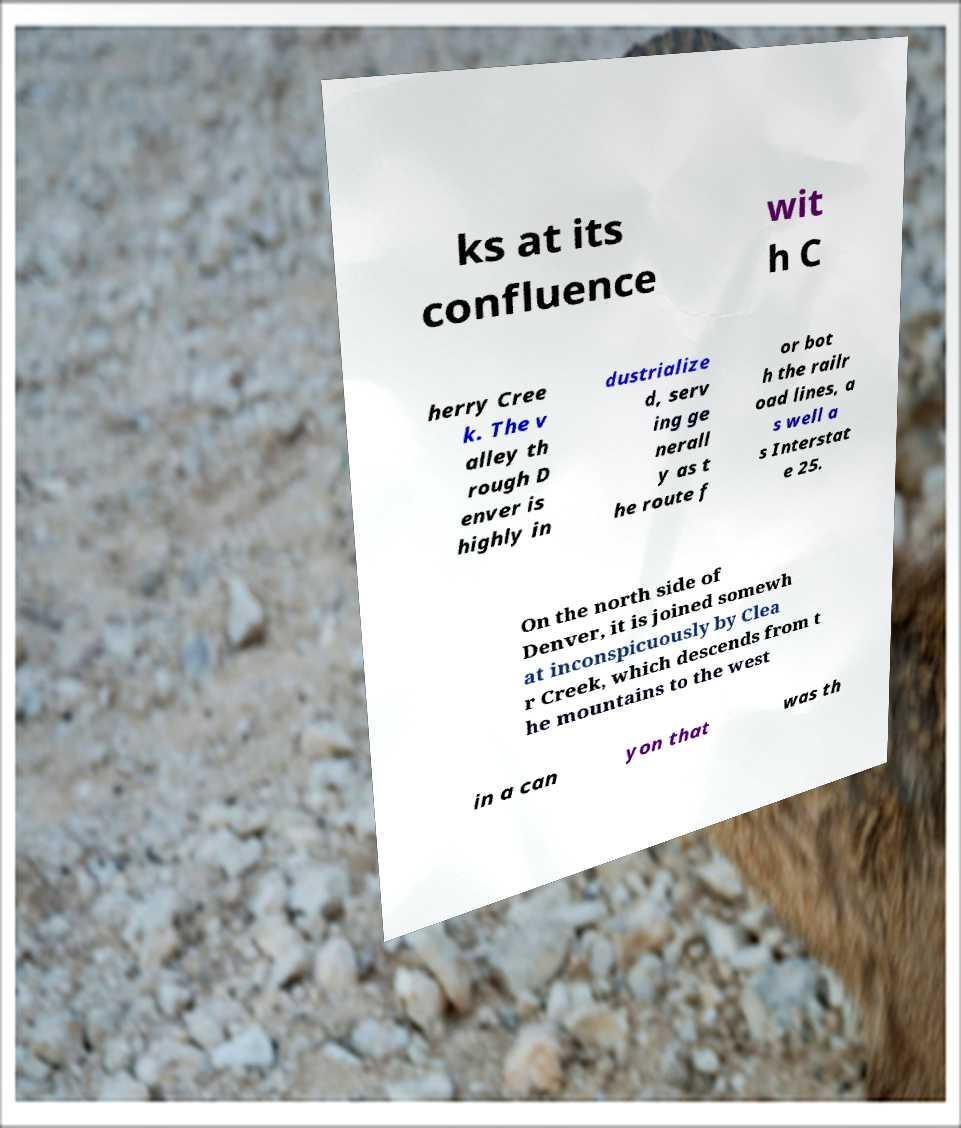What messages or text are displayed in this image? I need them in a readable, typed format. ks at its confluence wit h C herry Cree k. The v alley th rough D enver is highly in dustrialize d, serv ing ge nerall y as t he route f or bot h the railr oad lines, a s well a s Interstat e 25. On the north side of Denver, it is joined somewh at inconspicuously by Clea r Creek, which descends from t he mountains to the west in a can yon that was th 